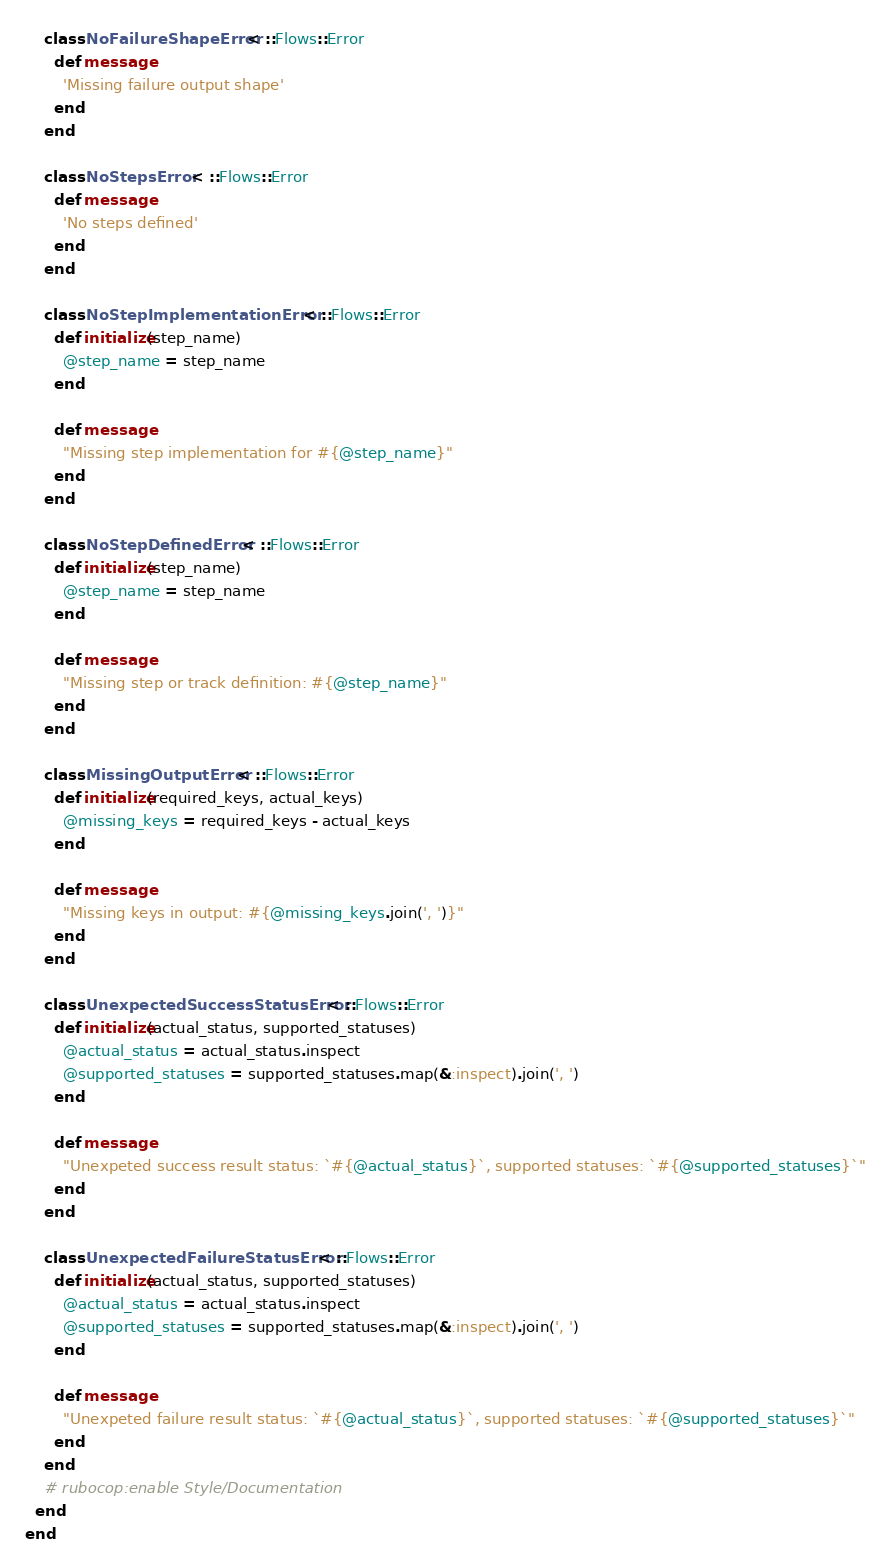<code> <loc_0><loc_0><loc_500><loc_500><_Ruby_>
    class NoFailureShapeError < ::Flows::Error
      def message
        'Missing failure output shape'
      end
    end

    class NoStepsError < ::Flows::Error
      def message
        'No steps defined'
      end
    end

    class NoStepImplementationError < ::Flows::Error
      def initialize(step_name)
        @step_name = step_name
      end

      def message
        "Missing step implementation for #{@step_name}"
      end
    end

    class NoStepDefinedError < ::Flows::Error
      def initialize(step_name)
        @step_name = step_name
      end

      def message
        "Missing step or track definition: #{@step_name}"
      end
    end

    class MissingOutputError < ::Flows::Error
      def initialize(required_keys, actual_keys)
        @missing_keys = required_keys - actual_keys
      end

      def message
        "Missing keys in output: #{@missing_keys.join(', ')}"
      end
    end

    class UnexpectedSuccessStatusError < ::Flows::Error
      def initialize(actual_status, supported_statuses)
        @actual_status = actual_status.inspect
        @supported_statuses = supported_statuses.map(&:inspect).join(', ')
      end

      def message
        "Unexpeted success result status: `#{@actual_status}`, supported statuses: `#{@supported_statuses}`"
      end
    end

    class UnexpectedFailureStatusError < ::Flows::Error
      def initialize(actual_status, supported_statuses)
        @actual_status = actual_status.inspect
        @supported_statuses = supported_statuses.map(&:inspect).join(', ')
      end

      def message
        "Unexpeted failure result status: `#{@actual_status}`, supported statuses: `#{@supported_statuses}`"
      end
    end
    # rubocop:enable Style/Documentation
  end
end
</code> 